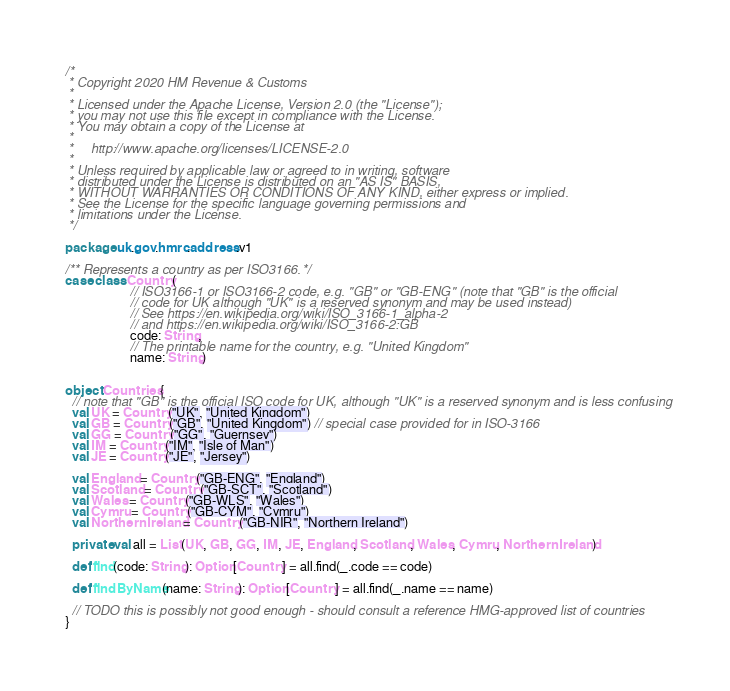<code> <loc_0><loc_0><loc_500><loc_500><_Scala_>/*
 * Copyright 2020 HM Revenue & Customs
 *
 * Licensed under the Apache License, Version 2.0 (the "License");
 * you may not use this file except in compliance with the License.
 * You may obtain a copy of the License at
 *
 *     http://www.apache.org/licenses/LICENSE-2.0
 *
 * Unless required by applicable law or agreed to in writing, software
 * distributed under the License is distributed on an "AS IS" BASIS,
 * WITHOUT WARRANTIES OR CONDITIONS OF ANY KIND, either express or implied.
 * See the License for the specific language governing permissions and
 * limitations under the License.
 */

package uk.gov.hmrc.address.v1

/** Represents a country as per ISO3166. */
case class Country(
                    // ISO3166-1 or ISO3166-2 code, e.g. "GB" or "GB-ENG" (note that "GB" is the official
                    // code for UK although "UK" is a reserved synonym and may be used instead)
                    // See https://en.wikipedia.org/wiki/ISO_3166-1_alpha-2
                    // and https://en.wikipedia.org/wiki/ISO_3166-2:GB
                    code: String,
                    // The printable name for the country, e.g. "United Kingdom"
                    name: String)


object Countries {
  // note that "GB" is the official ISO code for UK, although "UK" is a reserved synonym and is less confusing
  val UK = Country("UK", "United Kingdom")
  val GB = Country("GB", "United Kingdom") // special case provided for in ISO-3166
  val GG = Country("GG", "Guernsey")
  val IM = Country("IM", "Isle of Man")
  val JE = Country("JE", "Jersey")

  val England = Country("GB-ENG", "England")
  val Scotland = Country("GB-SCT", "Scotland")
  val Wales = Country("GB-WLS", "Wales")
  val Cymru = Country("GB-CYM", "Cymru")
  val NorthernIreland = Country("GB-NIR", "Northern Ireland")

  private val all = List(UK, GB, GG, IM, JE, England, Scotland, Wales, Cymru, NorthernIreland)

  def find(code: String): Option[Country] = all.find(_.code == code)

  def findByName(name: String): Option[Country] = all.find(_.name == name)

  // TODO this is possibly not good enough - should consult a reference HMG-approved list of countries
}
</code> 